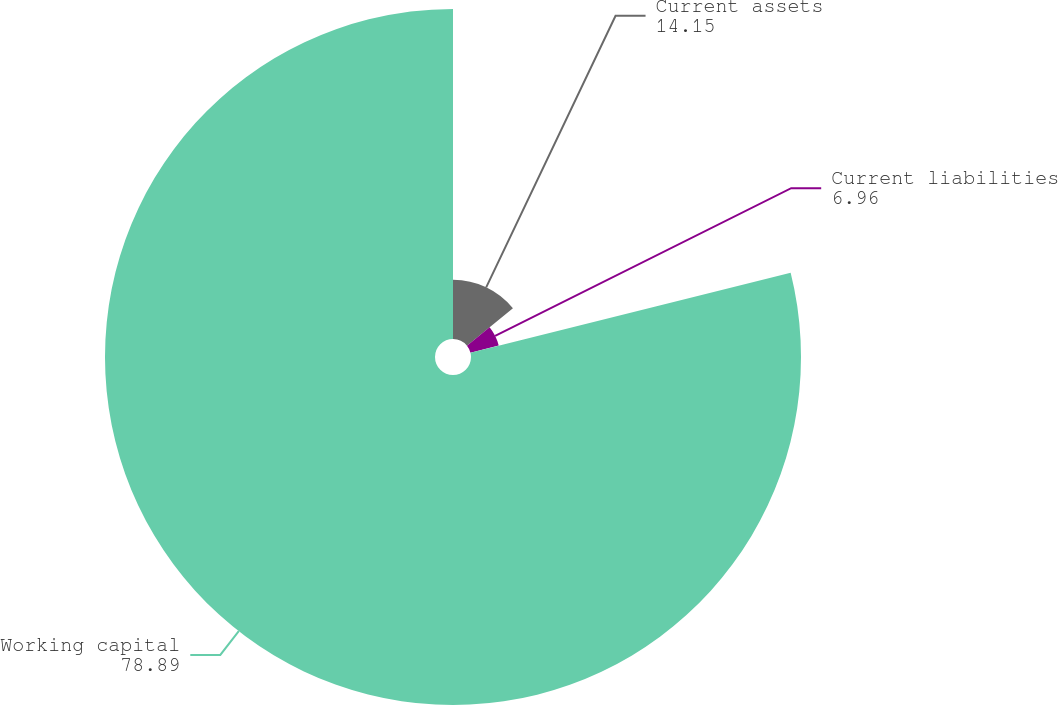Convert chart to OTSL. <chart><loc_0><loc_0><loc_500><loc_500><pie_chart><fcel>Current assets<fcel>Current liabilities<fcel>Working capital<nl><fcel>14.15%<fcel>6.96%<fcel>78.89%<nl></chart> 